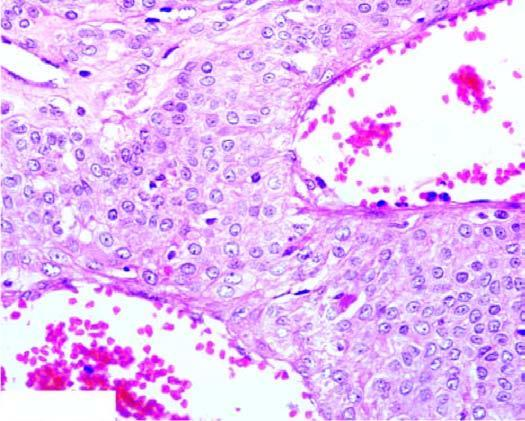re the cyst wall blood-filled vascular channels lined by endothelial cells and surrounded by nests and masses of glomus cells?
Answer the question using a single word or phrase. No 